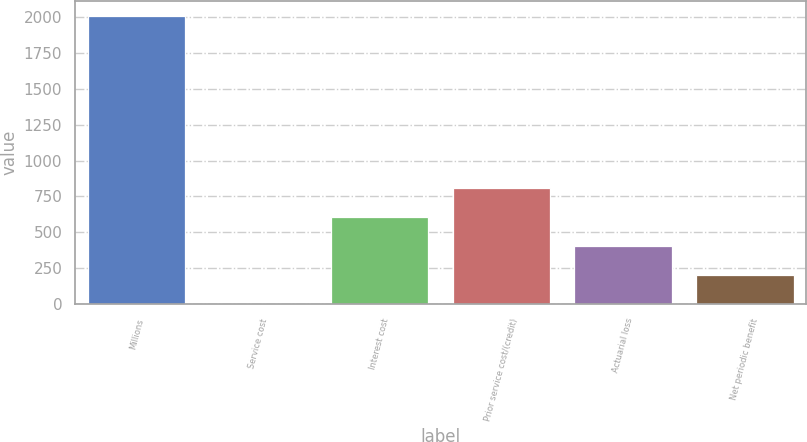Convert chart to OTSL. <chart><loc_0><loc_0><loc_500><loc_500><bar_chart><fcel>Millions<fcel>Service cost<fcel>Interest cost<fcel>Prior service cost/(credit)<fcel>Actuarial loss<fcel>Net periodic benefit<nl><fcel>2011<fcel>2<fcel>604.7<fcel>805.6<fcel>403.8<fcel>202.9<nl></chart> 